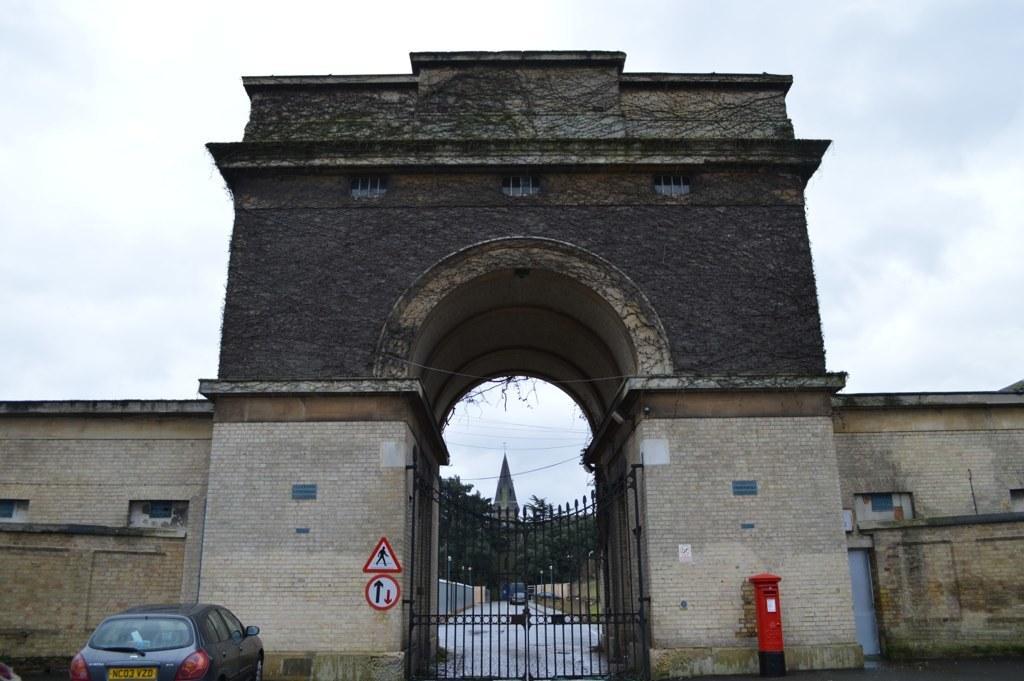How would you summarize this image in a sentence or two? In this image I can see an arch of the building and in center there is an iron gate. There is a mail box, sign board, a car in front of the building, and in the background there is a sky 